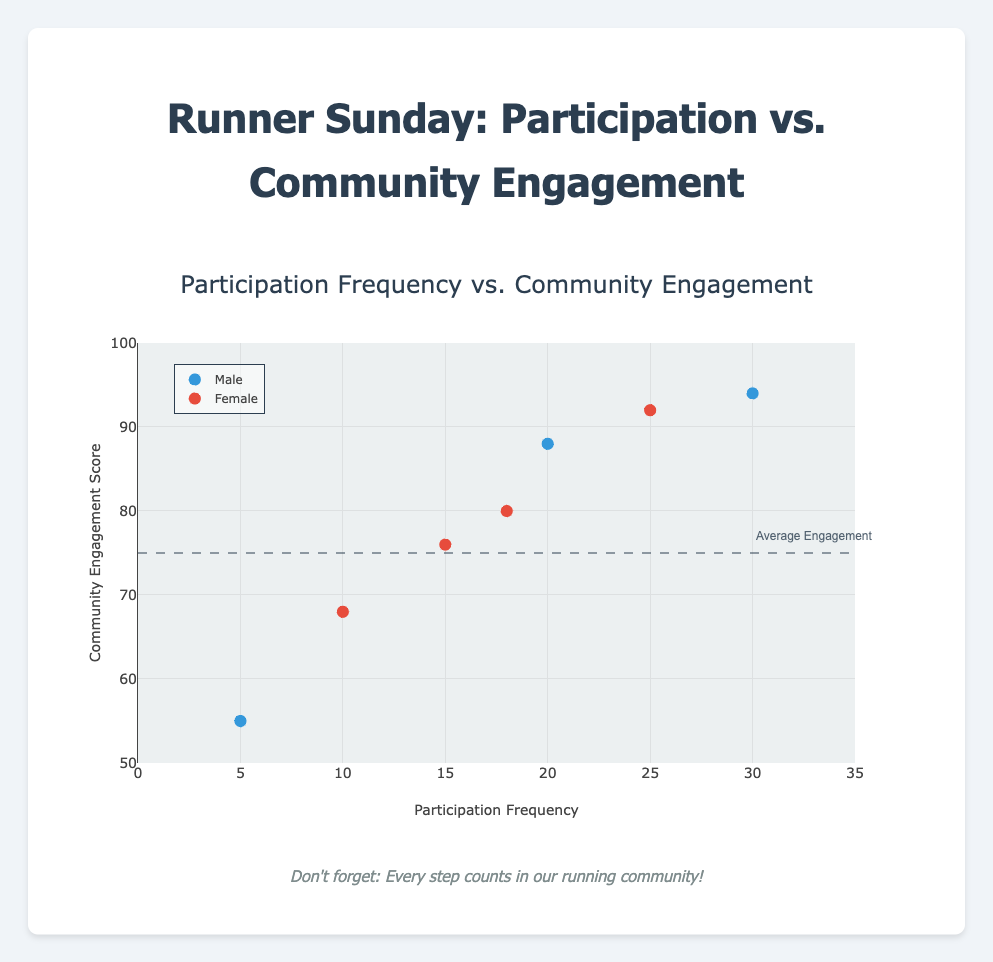What is the title of the plot? The title is usually placed at the top of a plot and it summarizes the main topic or relationship being visualized. In this case, the title "Participation Frequency vs. Community Engagement" indicates the plot compares these two variables.
Answer: Participation Frequency vs. Community Engagement How many participants are represented in the plot? To count the number of participants, look at the number of data points represented by markers in the plot. Each marker corresponds to a participant. There are seven markers in total.
Answer: Seven What is the highest Community Engagement Score among the male participants? Look at the scatter plot and identify the maximum "Community Engagement Score" value among the markers colored to represent male participants (blue). The highest score for males is 94, belonging to Michael Brown.
Answer: 94 Which participant has the lowest Participation Frequency? Identify the participant with the smallest "Participation Frequency" value on the x-axis. Chris Miller, with a frequency of 5, has the lowest participation frequency.
Answer: Chris Miller How does Jessica Wilson's Community Engagement Score compare with Emily Johnson's? Locate the markers representing Jessica Wilson and Emily Johnson. Jessica has a Community Engagement Score of 80, while Emily has a score of 76. Jessica's score is higher than Emily's by 4 points.
Answer: Jessica's score is higher What is the average Participation Frequency of the female participants? Identify the female participants (markers colored in red) and sum their "Participation Frequency" values: 25 (Jane) + 15 (Emily) + 10 (Sarah) + 18 (Jessica) = 68. There are 4 female participants, so their average frequency is 68/4 = 17.
Answer: 17 Is there a trend between Participation Frequency and Community Engagement Score for male participants? Plotting the data for male participants shows a positive trend: generally, higher participation frequency corresponds to higher engagement scores, supporting a positive correlation.
Answer: Positive trend What is the range of Community Engagement Scores for the entire group? Identify the minimum and maximum Community Engagement Scores across all data points. The minimum score is 55 (Chris Miller), and the maximum score is 94 (Michael Brown). Therefore, the range is 94 - 55 = 39.
Answer: 39 Which gender has a participant with the highest Participation Frequency? Determine which gender's participants reach the highest value on the Participation Frequency axis. Michael Brown, a male participant, has the highest participation rate at 30.
Answer: Male How many participants are above the "Average Engagement" line on the y-axis, and what does this indicate? Identify data points above the dashed "Average Engagement" line at y=75. Four participants (John Doe, Jane Smith, Michael Brown, and Jessica Wilson) have scores above this line. This indicates that these four participants have higher-than-average community engagement.
Answer: Four 